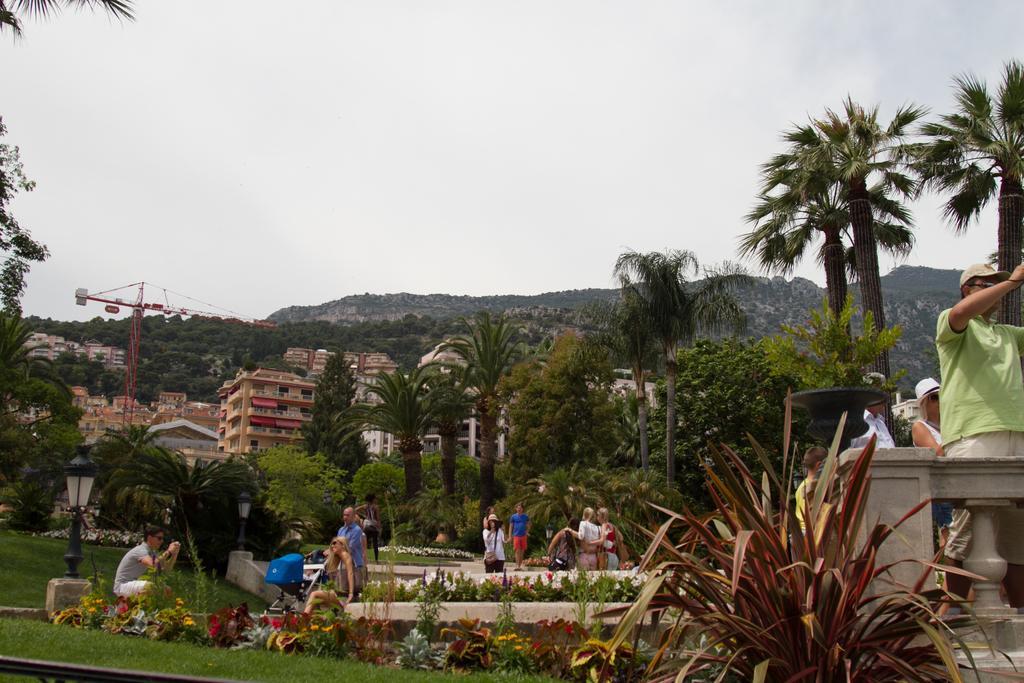Could you give a brief overview of what you see in this image? In this image I can see few trees, few flowers, some grass and few persons sitting and standing. I can see few buildings, few poles, a crane and few mountains. In the background I can see the sky. 